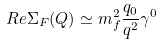<formula> <loc_0><loc_0><loc_500><loc_500>R e \Sigma _ { F } ( Q ) \simeq m _ { f } ^ { 2 } \frac { q _ { 0 } } { q ^ { 2 } } \gamma ^ { 0 }</formula> 